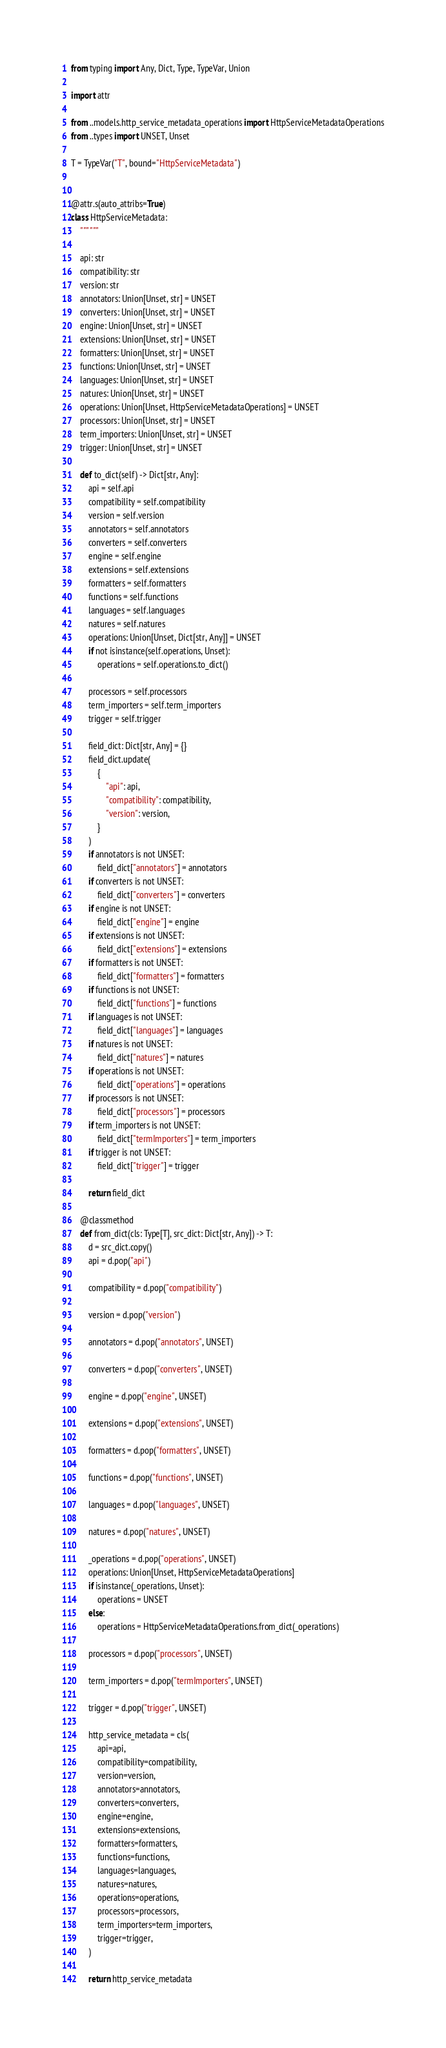<code> <loc_0><loc_0><loc_500><loc_500><_Python_>from typing import Any, Dict, Type, TypeVar, Union

import attr

from ..models.http_service_metadata_operations import HttpServiceMetadataOperations
from ..types import UNSET, Unset

T = TypeVar("T", bound="HttpServiceMetadata")


@attr.s(auto_attribs=True)
class HttpServiceMetadata:
    """ """

    api: str
    compatibility: str
    version: str
    annotators: Union[Unset, str] = UNSET
    converters: Union[Unset, str] = UNSET
    engine: Union[Unset, str] = UNSET
    extensions: Union[Unset, str] = UNSET
    formatters: Union[Unset, str] = UNSET
    functions: Union[Unset, str] = UNSET
    languages: Union[Unset, str] = UNSET
    natures: Union[Unset, str] = UNSET
    operations: Union[Unset, HttpServiceMetadataOperations] = UNSET
    processors: Union[Unset, str] = UNSET
    term_importers: Union[Unset, str] = UNSET
    trigger: Union[Unset, str] = UNSET

    def to_dict(self) -> Dict[str, Any]:
        api = self.api
        compatibility = self.compatibility
        version = self.version
        annotators = self.annotators
        converters = self.converters
        engine = self.engine
        extensions = self.extensions
        formatters = self.formatters
        functions = self.functions
        languages = self.languages
        natures = self.natures
        operations: Union[Unset, Dict[str, Any]] = UNSET
        if not isinstance(self.operations, Unset):
            operations = self.operations.to_dict()

        processors = self.processors
        term_importers = self.term_importers
        trigger = self.trigger

        field_dict: Dict[str, Any] = {}
        field_dict.update(
            {
                "api": api,
                "compatibility": compatibility,
                "version": version,
            }
        )
        if annotators is not UNSET:
            field_dict["annotators"] = annotators
        if converters is not UNSET:
            field_dict["converters"] = converters
        if engine is not UNSET:
            field_dict["engine"] = engine
        if extensions is not UNSET:
            field_dict["extensions"] = extensions
        if formatters is not UNSET:
            field_dict["formatters"] = formatters
        if functions is not UNSET:
            field_dict["functions"] = functions
        if languages is not UNSET:
            field_dict["languages"] = languages
        if natures is not UNSET:
            field_dict["natures"] = natures
        if operations is not UNSET:
            field_dict["operations"] = operations
        if processors is not UNSET:
            field_dict["processors"] = processors
        if term_importers is not UNSET:
            field_dict["termImporters"] = term_importers
        if trigger is not UNSET:
            field_dict["trigger"] = trigger

        return field_dict

    @classmethod
    def from_dict(cls: Type[T], src_dict: Dict[str, Any]) -> T:
        d = src_dict.copy()
        api = d.pop("api")

        compatibility = d.pop("compatibility")

        version = d.pop("version")

        annotators = d.pop("annotators", UNSET)

        converters = d.pop("converters", UNSET)

        engine = d.pop("engine", UNSET)

        extensions = d.pop("extensions", UNSET)

        formatters = d.pop("formatters", UNSET)

        functions = d.pop("functions", UNSET)

        languages = d.pop("languages", UNSET)

        natures = d.pop("natures", UNSET)

        _operations = d.pop("operations", UNSET)
        operations: Union[Unset, HttpServiceMetadataOperations]
        if isinstance(_operations, Unset):
            operations = UNSET
        else:
            operations = HttpServiceMetadataOperations.from_dict(_operations)

        processors = d.pop("processors", UNSET)

        term_importers = d.pop("termImporters", UNSET)

        trigger = d.pop("trigger", UNSET)

        http_service_metadata = cls(
            api=api,
            compatibility=compatibility,
            version=version,
            annotators=annotators,
            converters=converters,
            engine=engine,
            extensions=extensions,
            formatters=formatters,
            functions=functions,
            languages=languages,
            natures=natures,
            operations=operations,
            processors=processors,
            term_importers=term_importers,
            trigger=trigger,
        )

        return http_service_metadata
</code> 